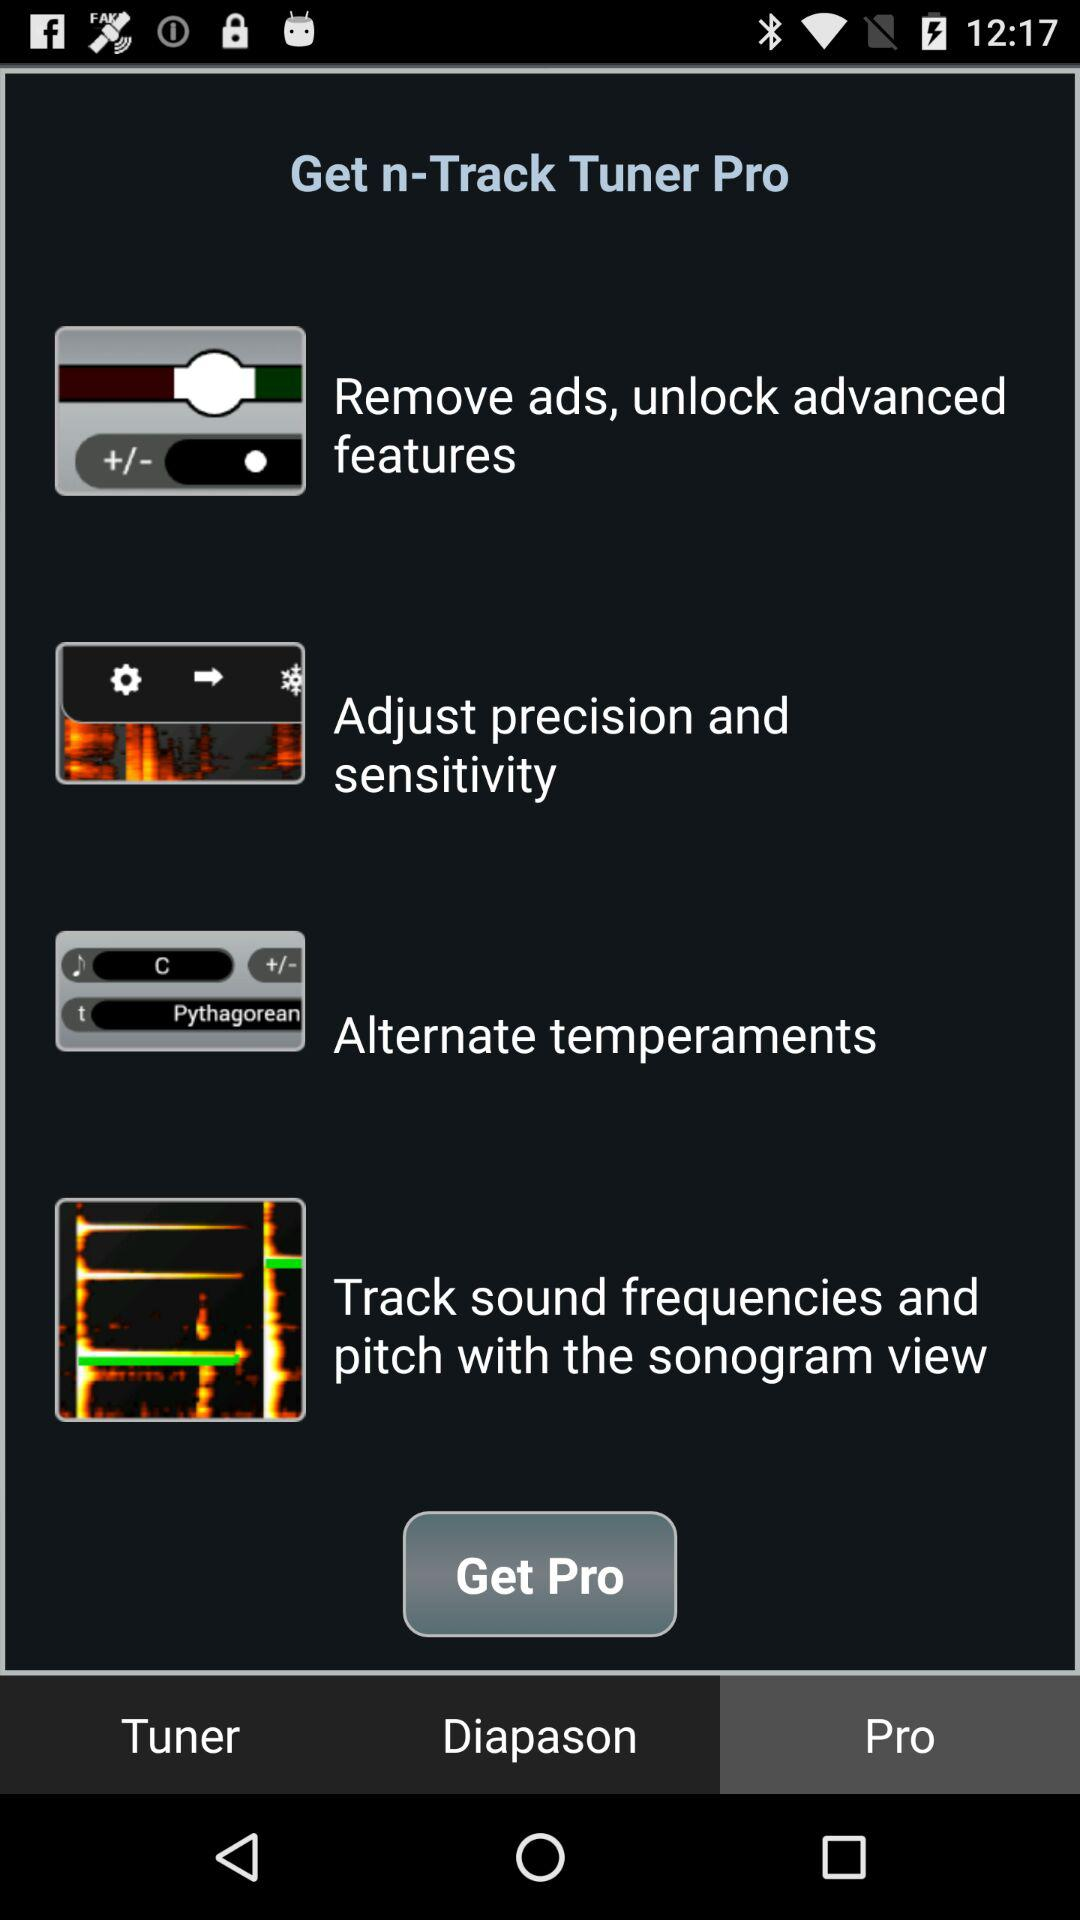Which tab is selected? The selected tab is "Pro". 